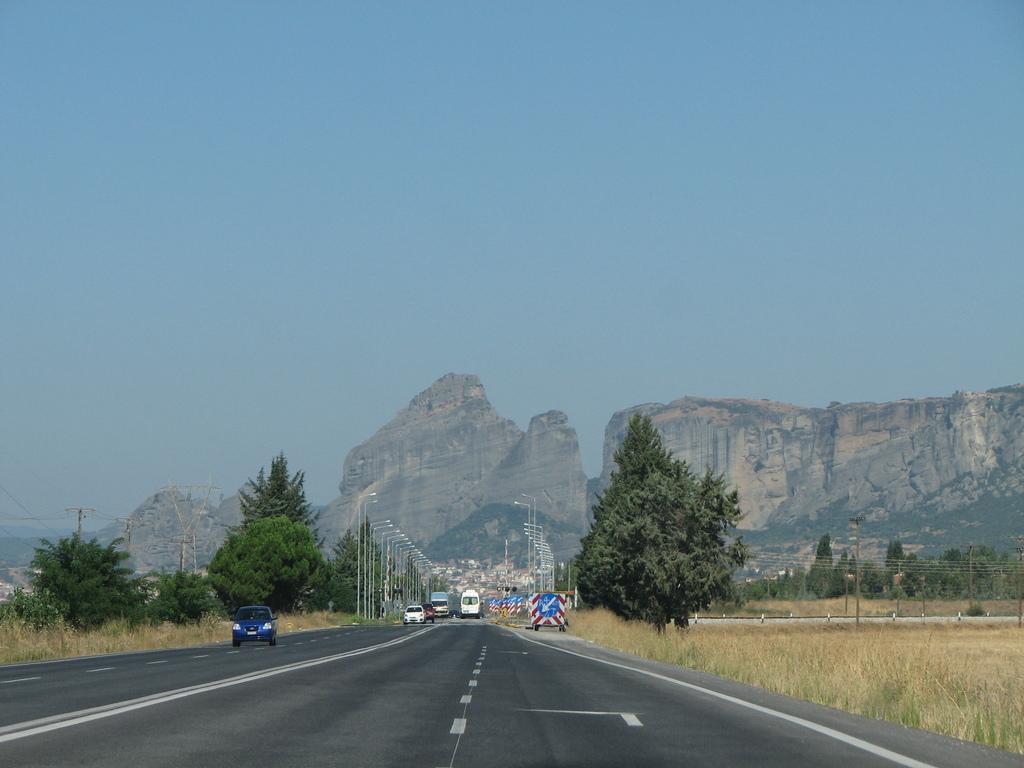Can you describe this image briefly? Here in this picture we can see number of vehicles present on the road over there and on the either side of the road we can see the ground is fully covered with grass and we can also see some plants and trees also present over there and we can see number of light posts present on the road and in the far we can see rocks that are covered with grass over there. 